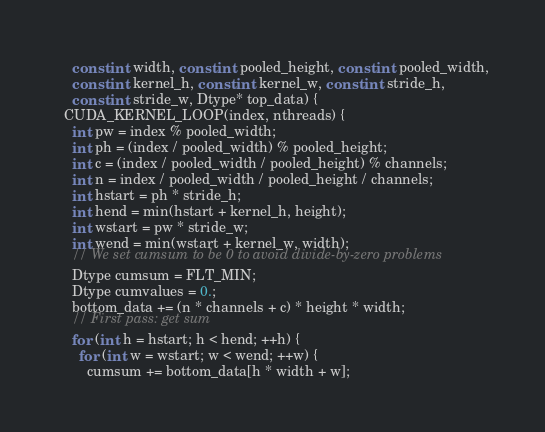<code> <loc_0><loc_0><loc_500><loc_500><_Cuda_>    const int width, const int pooled_height, const int pooled_width,
    const int kernel_h, const int kernel_w, const int stride_h,
    const int stride_w, Dtype* top_data) {
  CUDA_KERNEL_LOOP(index, nthreads) {
    int pw = index % pooled_width;
    int ph = (index / pooled_width) % pooled_height;
    int c = (index / pooled_width / pooled_height) % channels;
    int n = index / pooled_width / pooled_height / channels;
    int hstart = ph * stride_h;
    int hend = min(hstart + kernel_h, height);
    int wstart = pw * stride_w;
    int wend = min(wstart + kernel_w, width);
    // We set cumsum to be 0 to avoid divide-by-zero problems
    Dtype cumsum = FLT_MIN;
    Dtype cumvalues = 0.;
    bottom_data += (n * channels + c) * height * width;
    // First pass: get sum
    for (int h = hstart; h < hend; ++h) {
      for (int w = wstart; w < wend; ++w) {
        cumsum += bottom_data[h * width + w];</code> 